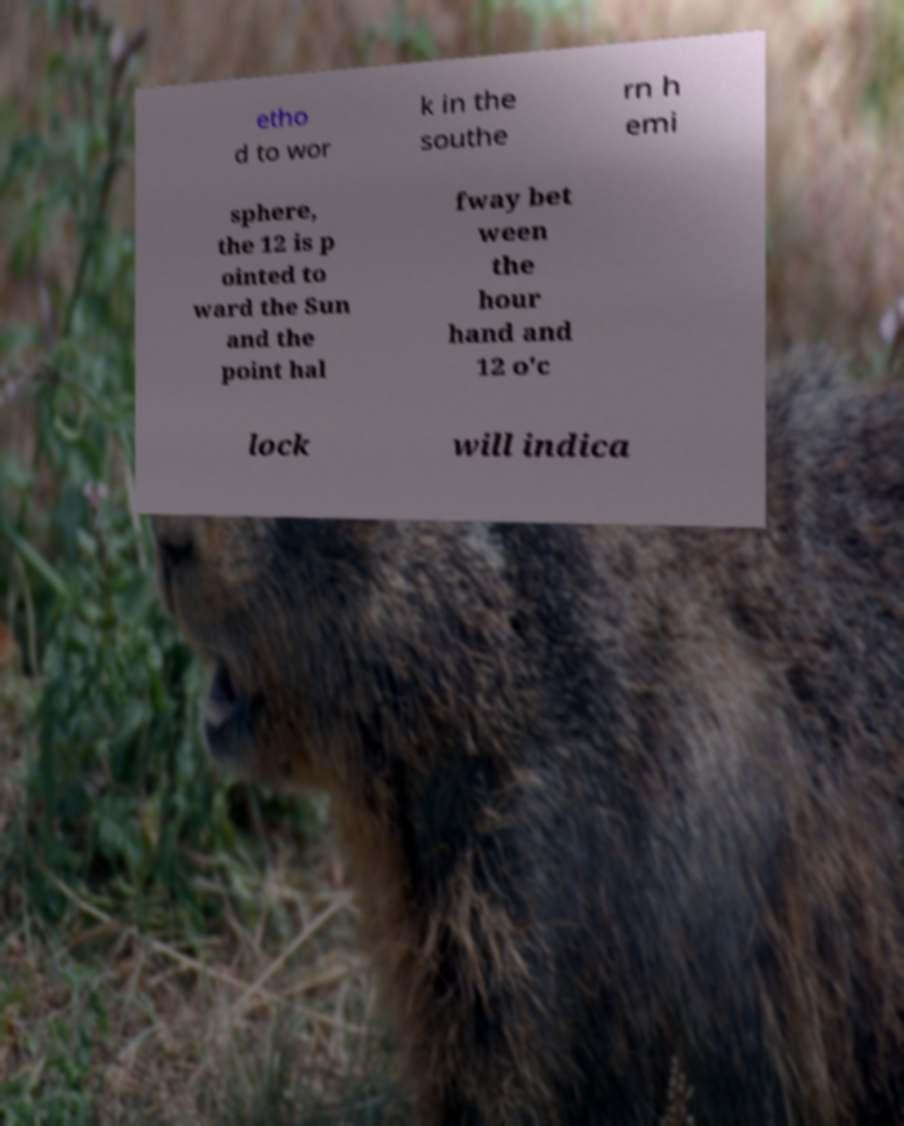Can you accurately transcribe the text from the provided image for me? etho d to wor k in the southe rn h emi sphere, the 12 is p ointed to ward the Sun and the point hal fway bet ween the hour hand and 12 o'c lock will indica 